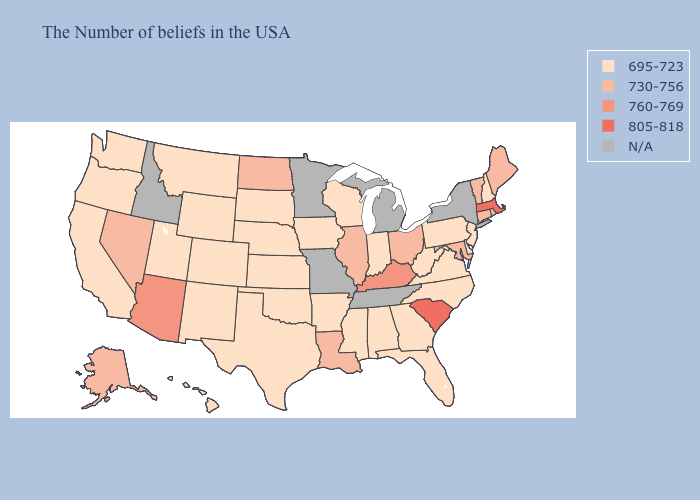Which states have the lowest value in the Northeast?
Write a very short answer. New Hampshire, New Jersey, Pennsylvania. Among the states that border Connecticut , which have the highest value?
Answer briefly. Massachusetts. What is the lowest value in the Northeast?
Write a very short answer. 695-723. What is the value of Kentucky?
Be succinct. 760-769. What is the highest value in states that border Maryland?
Answer briefly. 695-723. Name the states that have a value in the range 760-769?
Give a very brief answer. Kentucky, Arizona. Is the legend a continuous bar?
Short answer required. No. Among the states that border Vermont , which have the highest value?
Write a very short answer. Massachusetts. Name the states that have a value in the range 695-723?
Answer briefly. New Hampshire, New Jersey, Delaware, Pennsylvania, Virginia, North Carolina, West Virginia, Florida, Georgia, Indiana, Alabama, Wisconsin, Mississippi, Arkansas, Iowa, Kansas, Nebraska, Oklahoma, Texas, South Dakota, Wyoming, Colorado, New Mexico, Utah, Montana, California, Washington, Oregon, Hawaii. What is the lowest value in the MidWest?
Quick response, please. 695-723. Does the first symbol in the legend represent the smallest category?
Keep it brief. Yes. What is the value of Utah?
Short answer required. 695-723. What is the lowest value in the USA?
Quick response, please. 695-723. Does the map have missing data?
Give a very brief answer. Yes. 